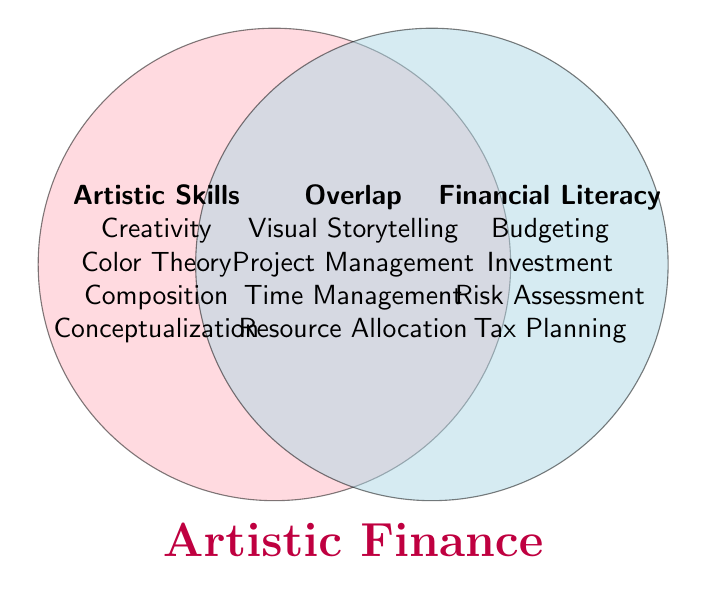How many categories are there for Artistic Skills? The section labeled "Artistic Skills" lists the different categories: Creativity, Color Theory, Composition, and Conceptualization. Count these items.
Answer: 4 How many elements are shared between Artistic Skills and Financial Literacy? Look at the section labeled "Overlap" where the skills that intersect both categories are listed: Visual Storytelling, Project Management, Time Management, and Resource Allocation. Count these items.
Answer: 4 Which skill is unique to Artistic Skills but not covered in Financial Literacy? Check the section labeled "Artistic Skills" and list each skill: Creativity, Color Theory, Composition, Conceptualization, and Aesthetic Sense. These are not found in the Financial Literacy section.
Answer: Aesthetic Sense What types of skills are considered both Artistic and Financial? Examine the "Overlap" section in the Venn Diagram where it lists the skills in both Artistic Skills and Financial Literacy: Visual Storytelling, Project Management, Time Management, and Resource Allocation.
Answer: Visual Storytelling, Project Management, Time Management, Resource Allocation Which skill useful in the "Overlap" can improve managing both artistic projects and financial budgets effectively? Look at skills in Overlap: Visual Storytelling, Project Management, Time Management, Resource Allocation, and select the most relevant for project and budget management.
Answer: Project Management What is the sum total of all unique skills and shared skills? Add the counts of Artistic Skills (5), Financial Literacy (5), and Overlap (4). 5 + 5 + 4 = 14
Answer: 14 Is "Visual Storytelling" considered a Financial Literacy skill? Check if "Visual Storytelling" is listed under Financial Literacy unique skills or Overlap. It is in the Overlap section, and thus applicable to Financial Literacy.
Answer: Yes 